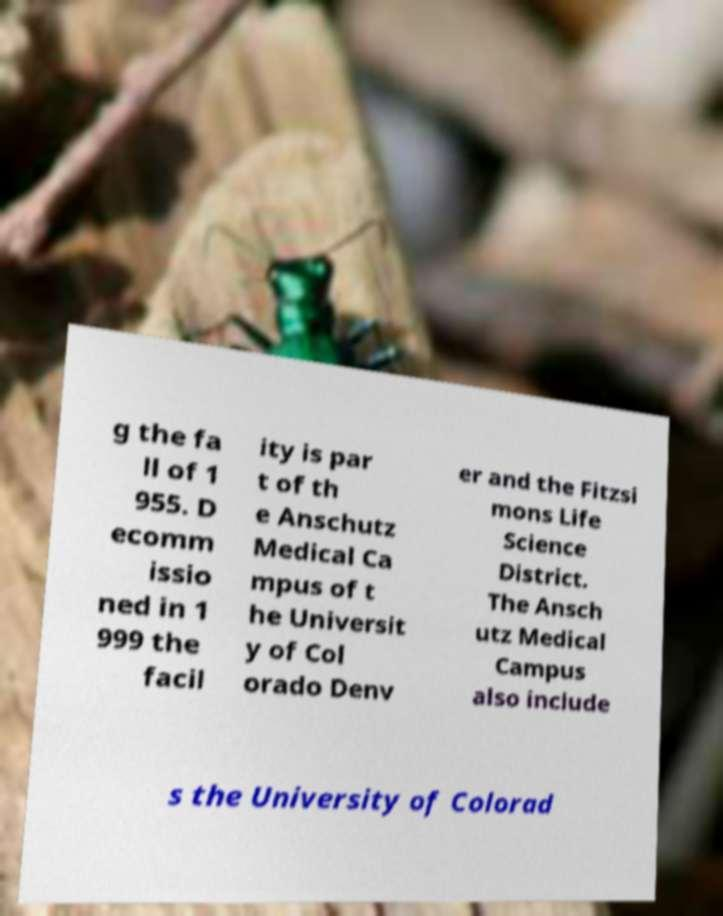For documentation purposes, I need the text within this image transcribed. Could you provide that? g the fa ll of 1 955. D ecomm issio ned in 1 999 the facil ity is par t of th e Anschutz Medical Ca mpus of t he Universit y of Col orado Denv er and the Fitzsi mons Life Science District. The Ansch utz Medical Campus also include s the University of Colorad 